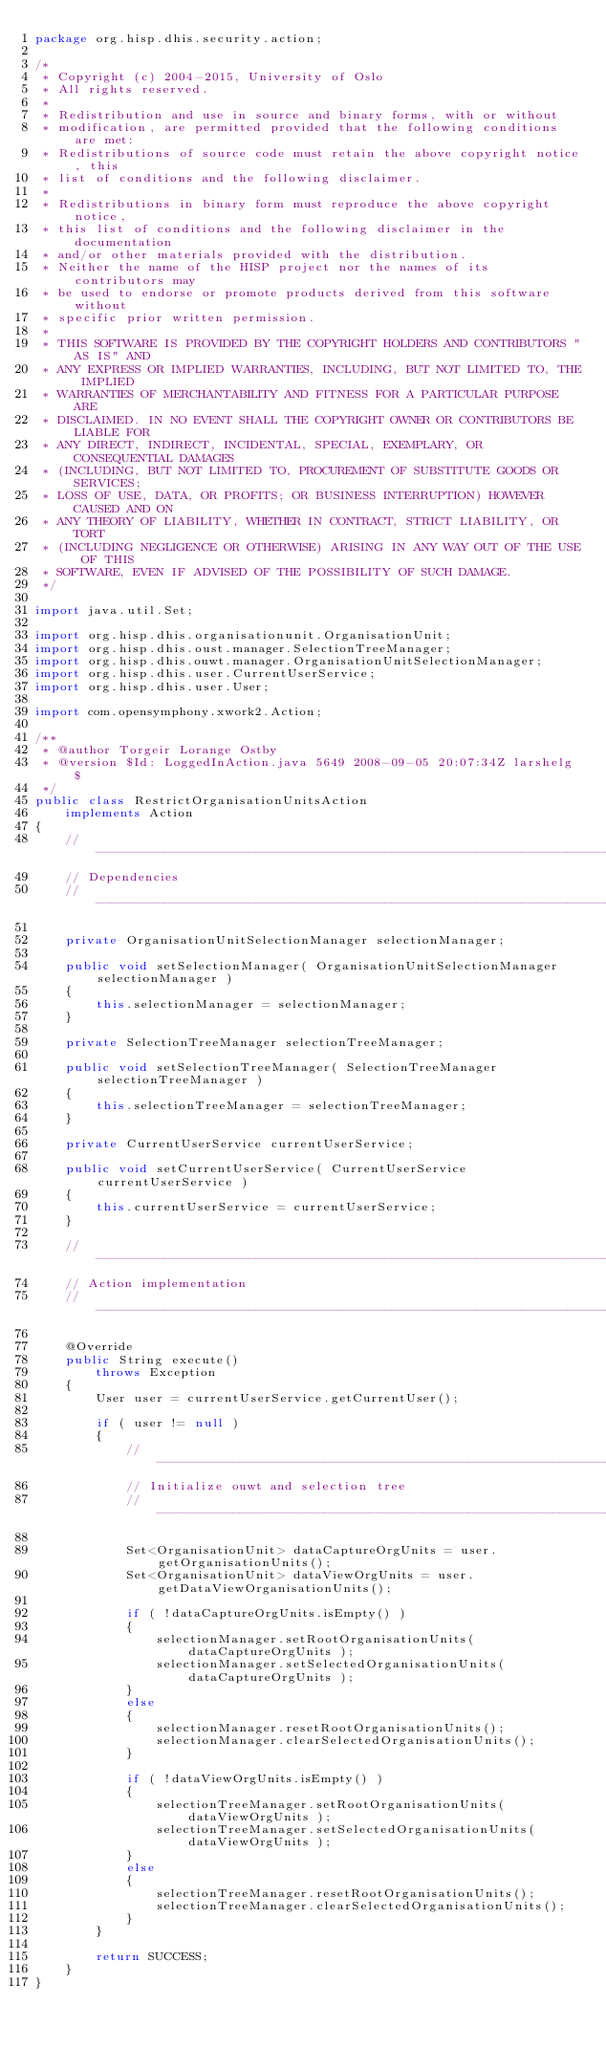Convert code to text. <code><loc_0><loc_0><loc_500><loc_500><_Java_>package org.hisp.dhis.security.action;

/*
 * Copyright (c) 2004-2015, University of Oslo
 * All rights reserved.
 *
 * Redistribution and use in source and binary forms, with or without
 * modification, are permitted provided that the following conditions are met:
 * Redistributions of source code must retain the above copyright notice, this
 * list of conditions and the following disclaimer.
 *
 * Redistributions in binary form must reproduce the above copyright notice,
 * this list of conditions and the following disclaimer in the documentation
 * and/or other materials provided with the distribution.
 * Neither the name of the HISP project nor the names of its contributors may
 * be used to endorse or promote products derived from this software without
 * specific prior written permission.
 *
 * THIS SOFTWARE IS PROVIDED BY THE COPYRIGHT HOLDERS AND CONTRIBUTORS "AS IS" AND
 * ANY EXPRESS OR IMPLIED WARRANTIES, INCLUDING, BUT NOT LIMITED TO, THE IMPLIED
 * WARRANTIES OF MERCHANTABILITY AND FITNESS FOR A PARTICULAR PURPOSE ARE
 * DISCLAIMED. IN NO EVENT SHALL THE COPYRIGHT OWNER OR CONTRIBUTORS BE LIABLE FOR
 * ANY DIRECT, INDIRECT, INCIDENTAL, SPECIAL, EXEMPLARY, OR CONSEQUENTIAL DAMAGES
 * (INCLUDING, BUT NOT LIMITED TO, PROCUREMENT OF SUBSTITUTE GOODS OR SERVICES;
 * LOSS OF USE, DATA, OR PROFITS; OR BUSINESS INTERRUPTION) HOWEVER CAUSED AND ON
 * ANY THEORY OF LIABILITY, WHETHER IN CONTRACT, STRICT LIABILITY, OR TORT
 * (INCLUDING NEGLIGENCE OR OTHERWISE) ARISING IN ANY WAY OUT OF THE USE OF THIS
 * SOFTWARE, EVEN IF ADVISED OF THE POSSIBILITY OF SUCH DAMAGE.
 */

import java.util.Set;

import org.hisp.dhis.organisationunit.OrganisationUnit;
import org.hisp.dhis.oust.manager.SelectionTreeManager;
import org.hisp.dhis.ouwt.manager.OrganisationUnitSelectionManager;
import org.hisp.dhis.user.CurrentUserService;
import org.hisp.dhis.user.User;

import com.opensymphony.xwork2.Action;

/**
 * @author Torgeir Lorange Ostby
 * @version $Id: LoggedInAction.java 5649 2008-09-05 20:07:34Z larshelg $
 */
public class RestrictOrganisationUnitsAction
    implements Action
{
    // -------------------------------------------------------------------------
    // Dependencies
    // -------------------------------------------------------------------------
	
    private OrganisationUnitSelectionManager selectionManager;

    public void setSelectionManager( OrganisationUnitSelectionManager selectionManager )
    {
        this.selectionManager = selectionManager;
    }
    
    private SelectionTreeManager selectionTreeManager;

    public void setSelectionTreeManager( SelectionTreeManager selectionTreeManager )
    {
        this.selectionTreeManager = selectionTreeManager;
    }
    
    private CurrentUserService currentUserService;

    public void setCurrentUserService( CurrentUserService currentUserService )
    {
        this.currentUserService = currentUserService;
    }
    
    // -------------------------------------------------------------------------
    // Action implementation
    // -------------------------------------------------------------------------

    @Override
    public String execute()
        throws Exception
    {
        User user = currentUserService.getCurrentUser();
        
        if ( user != null )
        {
            // -----------------------------------------------------------------
            // Initialize ouwt and selection tree
            // -----------------------------------------------------------------

            Set<OrganisationUnit> dataCaptureOrgUnits = user.getOrganisationUnits();
            Set<OrganisationUnit> dataViewOrgUnits = user.getDataViewOrganisationUnits();

            if ( !dataCaptureOrgUnits.isEmpty() )
            {
                selectionManager.setRootOrganisationUnits( dataCaptureOrgUnits );
                selectionManager.setSelectedOrganisationUnits( dataCaptureOrgUnits );
            }
            else
            {
                selectionManager.resetRootOrganisationUnits();
                selectionManager.clearSelectedOrganisationUnits();
            }
            
            if ( !dataViewOrgUnits.isEmpty() )
            {                
                selectionTreeManager.setRootOrganisationUnits( dataViewOrgUnits );                
                selectionTreeManager.setSelectedOrganisationUnits( dataViewOrgUnits );
            }
            else
            {                
                selectionTreeManager.resetRootOrganisationUnits();                
                selectionTreeManager.clearSelectedOrganisationUnits();
            }
        }

        return SUCCESS;
    }
}
</code> 